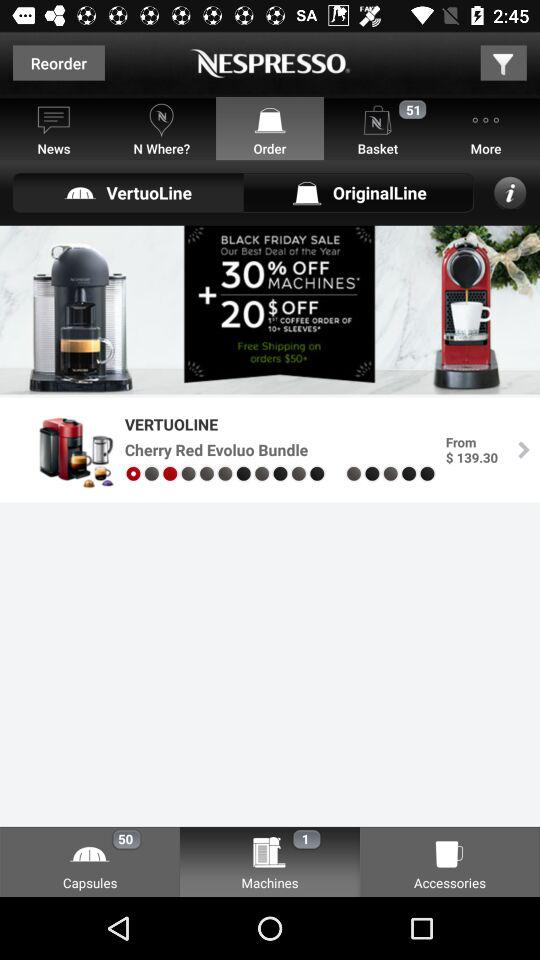Which option is selected? The selected options are "Order", "VertuoLine" and "Machines". 